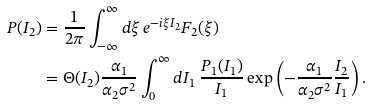<formula> <loc_0><loc_0><loc_500><loc_500>P ( I _ { 2 } ) & = \frac { 1 } { 2 \pi } \int _ { - \infty } ^ { \infty } d \xi \, e ^ { - i \xi I _ { 2 } } F _ { 2 } ( \xi ) \\ & = \Theta ( I _ { 2 } ) \frac { \alpha _ { 1 } } { \alpha _ { 2 } \sigma ^ { 2 } } \int _ { 0 } ^ { \infty } d I _ { 1 } \, \frac { P _ { 1 } ( I _ { 1 } ) } { I _ { 1 } } \exp \left ( - \frac { \alpha _ { 1 } } { \alpha _ { 2 } \sigma ^ { 2 } } \frac { I _ { 2 } } { I _ { 1 } } \right ) .</formula> 